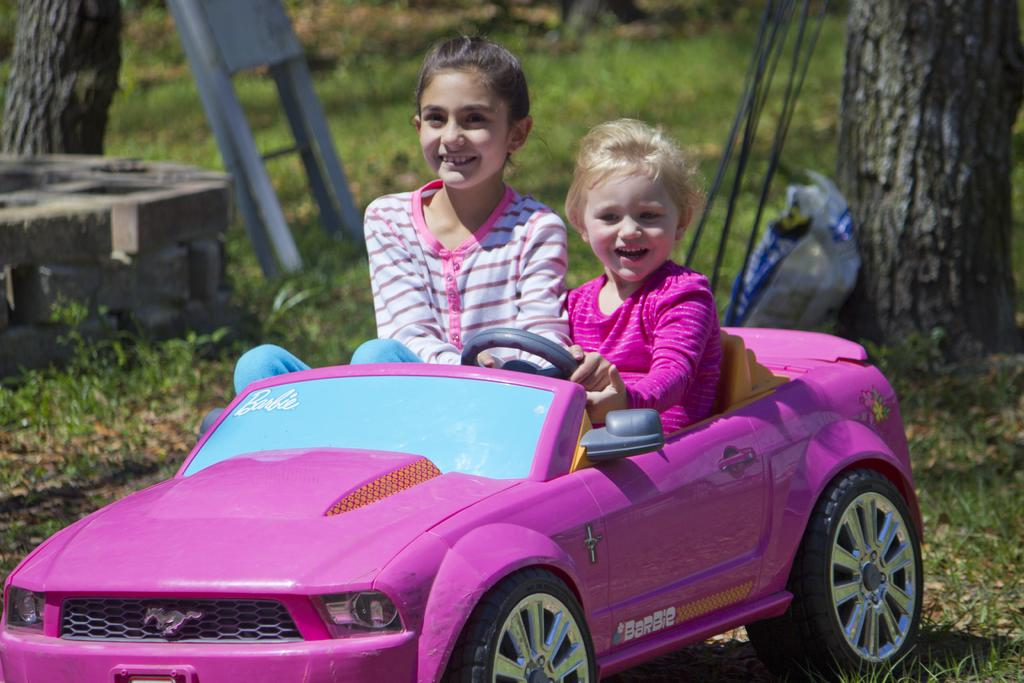What type of surface is visible in the image? There is grass in the image. What object is present in the grass? There is a toy car in the image. Who or what is interacting with the toy car? Two people are sitting in the toy car. What type of insurance do the people sitting in the toy car have? There is no information about insurance in the image, as it features a toy car and people sitting in it. 